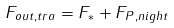<formula> <loc_0><loc_0><loc_500><loc_500>F _ { o u t , t r a } = F _ { * } + F _ { P , n i g h t }</formula> 